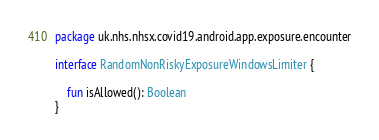<code> <loc_0><loc_0><loc_500><loc_500><_Kotlin_>package uk.nhs.nhsx.covid19.android.app.exposure.encounter

interface RandomNonRiskyExposureWindowsLimiter {

    fun isAllowed(): Boolean
}
</code> 